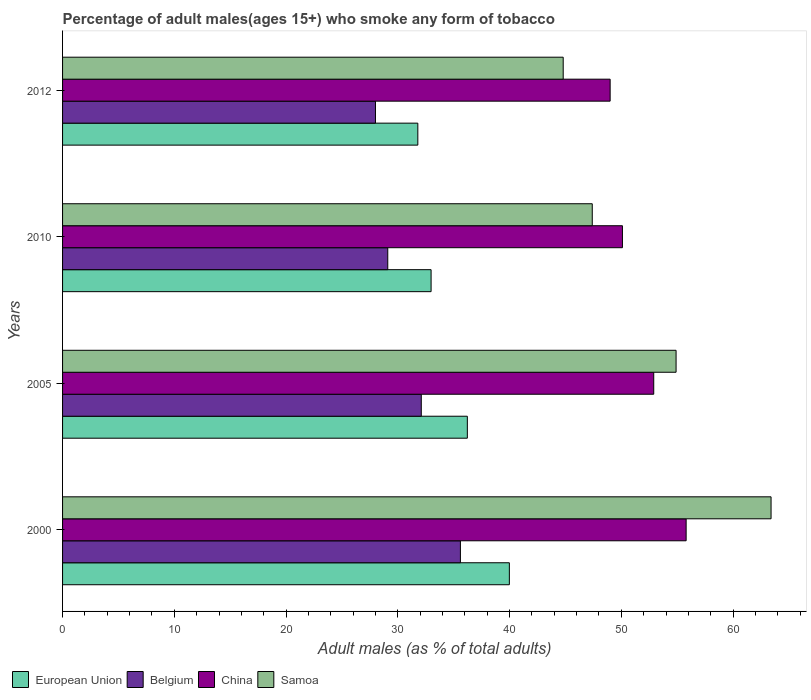How many different coloured bars are there?
Ensure brevity in your answer.  4. How many groups of bars are there?
Provide a succinct answer. 4. Are the number of bars per tick equal to the number of legend labels?
Ensure brevity in your answer.  Yes. Are the number of bars on each tick of the Y-axis equal?
Your response must be concise. Yes. What is the label of the 1st group of bars from the top?
Ensure brevity in your answer.  2012. In how many cases, is the number of bars for a given year not equal to the number of legend labels?
Your answer should be compact. 0. What is the percentage of adult males who smoke in China in 2000?
Offer a very short reply. 55.8. Across all years, what is the maximum percentage of adult males who smoke in China?
Your answer should be very brief. 55.8. Across all years, what is the minimum percentage of adult males who smoke in European Union?
Offer a terse response. 31.79. What is the total percentage of adult males who smoke in European Union in the graph?
Give a very brief answer. 140.97. What is the difference between the percentage of adult males who smoke in European Union in 2000 and that in 2012?
Give a very brief answer. 8.19. What is the difference between the percentage of adult males who smoke in European Union in 2010 and the percentage of adult males who smoke in China in 2000?
Ensure brevity in your answer.  -22.82. What is the average percentage of adult males who smoke in Belgium per year?
Your answer should be very brief. 31.2. In the year 2000, what is the difference between the percentage of adult males who smoke in European Union and percentage of adult males who smoke in Belgium?
Make the answer very short. 4.38. In how many years, is the percentage of adult males who smoke in Samoa greater than 30 %?
Offer a terse response. 4. What is the ratio of the percentage of adult males who smoke in European Union in 2000 to that in 2010?
Your answer should be compact. 1.21. Is the percentage of adult males who smoke in European Union in 2005 less than that in 2010?
Keep it short and to the point. No. Is the difference between the percentage of adult males who smoke in European Union in 2000 and 2005 greater than the difference between the percentage of adult males who smoke in Belgium in 2000 and 2005?
Keep it short and to the point. Yes. What is the difference between the highest and the second highest percentage of adult males who smoke in China?
Ensure brevity in your answer.  2.9. What is the difference between the highest and the lowest percentage of adult males who smoke in Samoa?
Keep it short and to the point. 18.6. In how many years, is the percentage of adult males who smoke in China greater than the average percentage of adult males who smoke in China taken over all years?
Provide a short and direct response. 2. Is the sum of the percentage of adult males who smoke in China in 2010 and 2012 greater than the maximum percentage of adult males who smoke in Samoa across all years?
Your answer should be very brief. Yes. What does the 3rd bar from the bottom in 2005 represents?
Make the answer very short. China. Are all the bars in the graph horizontal?
Offer a terse response. Yes. What is the difference between two consecutive major ticks on the X-axis?
Give a very brief answer. 10. Are the values on the major ticks of X-axis written in scientific E-notation?
Give a very brief answer. No. Does the graph contain grids?
Make the answer very short. No. How are the legend labels stacked?
Make the answer very short. Horizontal. What is the title of the graph?
Your answer should be very brief. Percentage of adult males(ages 15+) who smoke any form of tobacco. Does "Albania" appear as one of the legend labels in the graph?
Provide a succinct answer. No. What is the label or title of the X-axis?
Give a very brief answer. Adult males (as % of total adults). What is the label or title of the Y-axis?
Offer a very short reply. Years. What is the Adult males (as % of total adults) of European Union in 2000?
Your answer should be very brief. 39.98. What is the Adult males (as % of total adults) in Belgium in 2000?
Ensure brevity in your answer.  35.6. What is the Adult males (as % of total adults) in China in 2000?
Give a very brief answer. 55.8. What is the Adult males (as % of total adults) of Samoa in 2000?
Make the answer very short. 63.4. What is the Adult males (as % of total adults) of European Union in 2005?
Your answer should be compact. 36.22. What is the Adult males (as % of total adults) in Belgium in 2005?
Your answer should be very brief. 32.1. What is the Adult males (as % of total adults) in China in 2005?
Offer a terse response. 52.9. What is the Adult males (as % of total adults) in Samoa in 2005?
Your response must be concise. 54.9. What is the Adult males (as % of total adults) in European Union in 2010?
Your answer should be compact. 32.98. What is the Adult males (as % of total adults) in Belgium in 2010?
Provide a short and direct response. 29.1. What is the Adult males (as % of total adults) of China in 2010?
Make the answer very short. 50.1. What is the Adult males (as % of total adults) in Samoa in 2010?
Provide a succinct answer. 47.4. What is the Adult males (as % of total adults) of European Union in 2012?
Provide a short and direct response. 31.79. What is the Adult males (as % of total adults) in China in 2012?
Give a very brief answer. 49. What is the Adult males (as % of total adults) of Samoa in 2012?
Offer a terse response. 44.8. Across all years, what is the maximum Adult males (as % of total adults) of European Union?
Provide a succinct answer. 39.98. Across all years, what is the maximum Adult males (as % of total adults) of Belgium?
Make the answer very short. 35.6. Across all years, what is the maximum Adult males (as % of total adults) of China?
Provide a succinct answer. 55.8. Across all years, what is the maximum Adult males (as % of total adults) of Samoa?
Give a very brief answer. 63.4. Across all years, what is the minimum Adult males (as % of total adults) in European Union?
Offer a very short reply. 31.79. Across all years, what is the minimum Adult males (as % of total adults) in Samoa?
Provide a short and direct response. 44.8. What is the total Adult males (as % of total adults) of European Union in the graph?
Give a very brief answer. 140.97. What is the total Adult males (as % of total adults) of Belgium in the graph?
Provide a succinct answer. 124.8. What is the total Adult males (as % of total adults) in China in the graph?
Ensure brevity in your answer.  207.8. What is the total Adult males (as % of total adults) of Samoa in the graph?
Offer a terse response. 210.5. What is the difference between the Adult males (as % of total adults) in European Union in 2000 and that in 2005?
Keep it short and to the point. 3.76. What is the difference between the Adult males (as % of total adults) in Samoa in 2000 and that in 2005?
Ensure brevity in your answer.  8.5. What is the difference between the Adult males (as % of total adults) of European Union in 2000 and that in 2010?
Give a very brief answer. 7. What is the difference between the Adult males (as % of total adults) of China in 2000 and that in 2010?
Provide a short and direct response. 5.7. What is the difference between the Adult males (as % of total adults) in European Union in 2000 and that in 2012?
Give a very brief answer. 8.19. What is the difference between the Adult males (as % of total adults) of Samoa in 2000 and that in 2012?
Ensure brevity in your answer.  18.6. What is the difference between the Adult males (as % of total adults) of European Union in 2005 and that in 2010?
Keep it short and to the point. 3.24. What is the difference between the Adult males (as % of total adults) of China in 2005 and that in 2010?
Offer a terse response. 2.8. What is the difference between the Adult males (as % of total adults) in European Union in 2005 and that in 2012?
Make the answer very short. 4.43. What is the difference between the Adult males (as % of total adults) of China in 2005 and that in 2012?
Keep it short and to the point. 3.9. What is the difference between the Adult males (as % of total adults) in European Union in 2010 and that in 2012?
Keep it short and to the point. 1.19. What is the difference between the Adult males (as % of total adults) of European Union in 2000 and the Adult males (as % of total adults) of Belgium in 2005?
Your answer should be very brief. 7.88. What is the difference between the Adult males (as % of total adults) in European Union in 2000 and the Adult males (as % of total adults) in China in 2005?
Offer a very short reply. -12.92. What is the difference between the Adult males (as % of total adults) in European Union in 2000 and the Adult males (as % of total adults) in Samoa in 2005?
Keep it short and to the point. -14.92. What is the difference between the Adult males (as % of total adults) of Belgium in 2000 and the Adult males (as % of total adults) of China in 2005?
Your response must be concise. -17.3. What is the difference between the Adult males (as % of total adults) in Belgium in 2000 and the Adult males (as % of total adults) in Samoa in 2005?
Offer a very short reply. -19.3. What is the difference between the Adult males (as % of total adults) of China in 2000 and the Adult males (as % of total adults) of Samoa in 2005?
Your response must be concise. 0.9. What is the difference between the Adult males (as % of total adults) in European Union in 2000 and the Adult males (as % of total adults) in Belgium in 2010?
Your response must be concise. 10.88. What is the difference between the Adult males (as % of total adults) in European Union in 2000 and the Adult males (as % of total adults) in China in 2010?
Give a very brief answer. -10.12. What is the difference between the Adult males (as % of total adults) in European Union in 2000 and the Adult males (as % of total adults) in Samoa in 2010?
Your answer should be compact. -7.42. What is the difference between the Adult males (as % of total adults) in Belgium in 2000 and the Adult males (as % of total adults) in China in 2010?
Ensure brevity in your answer.  -14.5. What is the difference between the Adult males (as % of total adults) of Belgium in 2000 and the Adult males (as % of total adults) of Samoa in 2010?
Your response must be concise. -11.8. What is the difference between the Adult males (as % of total adults) in European Union in 2000 and the Adult males (as % of total adults) in Belgium in 2012?
Your answer should be very brief. 11.98. What is the difference between the Adult males (as % of total adults) in European Union in 2000 and the Adult males (as % of total adults) in China in 2012?
Make the answer very short. -9.02. What is the difference between the Adult males (as % of total adults) of European Union in 2000 and the Adult males (as % of total adults) of Samoa in 2012?
Give a very brief answer. -4.82. What is the difference between the Adult males (as % of total adults) of China in 2000 and the Adult males (as % of total adults) of Samoa in 2012?
Provide a succinct answer. 11. What is the difference between the Adult males (as % of total adults) of European Union in 2005 and the Adult males (as % of total adults) of Belgium in 2010?
Provide a succinct answer. 7.12. What is the difference between the Adult males (as % of total adults) of European Union in 2005 and the Adult males (as % of total adults) of China in 2010?
Make the answer very short. -13.88. What is the difference between the Adult males (as % of total adults) in European Union in 2005 and the Adult males (as % of total adults) in Samoa in 2010?
Your answer should be very brief. -11.18. What is the difference between the Adult males (as % of total adults) in Belgium in 2005 and the Adult males (as % of total adults) in Samoa in 2010?
Offer a very short reply. -15.3. What is the difference between the Adult males (as % of total adults) in China in 2005 and the Adult males (as % of total adults) in Samoa in 2010?
Make the answer very short. 5.5. What is the difference between the Adult males (as % of total adults) of European Union in 2005 and the Adult males (as % of total adults) of Belgium in 2012?
Keep it short and to the point. 8.22. What is the difference between the Adult males (as % of total adults) in European Union in 2005 and the Adult males (as % of total adults) in China in 2012?
Your response must be concise. -12.78. What is the difference between the Adult males (as % of total adults) of European Union in 2005 and the Adult males (as % of total adults) of Samoa in 2012?
Keep it short and to the point. -8.58. What is the difference between the Adult males (as % of total adults) of Belgium in 2005 and the Adult males (as % of total adults) of China in 2012?
Give a very brief answer. -16.9. What is the difference between the Adult males (as % of total adults) of Belgium in 2005 and the Adult males (as % of total adults) of Samoa in 2012?
Ensure brevity in your answer.  -12.7. What is the difference between the Adult males (as % of total adults) in China in 2005 and the Adult males (as % of total adults) in Samoa in 2012?
Provide a short and direct response. 8.1. What is the difference between the Adult males (as % of total adults) in European Union in 2010 and the Adult males (as % of total adults) in Belgium in 2012?
Provide a short and direct response. 4.98. What is the difference between the Adult males (as % of total adults) of European Union in 2010 and the Adult males (as % of total adults) of China in 2012?
Provide a short and direct response. -16.02. What is the difference between the Adult males (as % of total adults) of European Union in 2010 and the Adult males (as % of total adults) of Samoa in 2012?
Provide a succinct answer. -11.82. What is the difference between the Adult males (as % of total adults) of Belgium in 2010 and the Adult males (as % of total adults) of China in 2012?
Your answer should be very brief. -19.9. What is the difference between the Adult males (as % of total adults) of Belgium in 2010 and the Adult males (as % of total adults) of Samoa in 2012?
Make the answer very short. -15.7. What is the average Adult males (as % of total adults) in European Union per year?
Keep it short and to the point. 35.24. What is the average Adult males (as % of total adults) of Belgium per year?
Your answer should be compact. 31.2. What is the average Adult males (as % of total adults) in China per year?
Ensure brevity in your answer.  51.95. What is the average Adult males (as % of total adults) of Samoa per year?
Give a very brief answer. 52.62. In the year 2000, what is the difference between the Adult males (as % of total adults) of European Union and Adult males (as % of total adults) of Belgium?
Provide a succinct answer. 4.38. In the year 2000, what is the difference between the Adult males (as % of total adults) of European Union and Adult males (as % of total adults) of China?
Give a very brief answer. -15.82. In the year 2000, what is the difference between the Adult males (as % of total adults) of European Union and Adult males (as % of total adults) of Samoa?
Your answer should be compact. -23.42. In the year 2000, what is the difference between the Adult males (as % of total adults) in Belgium and Adult males (as % of total adults) in China?
Give a very brief answer. -20.2. In the year 2000, what is the difference between the Adult males (as % of total adults) in Belgium and Adult males (as % of total adults) in Samoa?
Make the answer very short. -27.8. In the year 2000, what is the difference between the Adult males (as % of total adults) in China and Adult males (as % of total adults) in Samoa?
Your answer should be compact. -7.6. In the year 2005, what is the difference between the Adult males (as % of total adults) in European Union and Adult males (as % of total adults) in Belgium?
Ensure brevity in your answer.  4.12. In the year 2005, what is the difference between the Adult males (as % of total adults) in European Union and Adult males (as % of total adults) in China?
Your response must be concise. -16.68. In the year 2005, what is the difference between the Adult males (as % of total adults) of European Union and Adult males (as % of total adults) of Samoa?
Provide a short and direct response. -18.68. In the year 2005, what is the difference between the Adult males (as % of total adults) in Belgium and Adult males (as % of total adults) in China?
Provide a short and direct response. -20.8. In the year 2005, what is the difference between the Adult males (as % of total adults) of Belgium and Adult males (as % of total adults) of Samoa?
Offer a terse response. -22.8. In the year 2005, what is the difference between the Adult males (as % of total adults) of China and Adult males (as % of total adults) of Samoa?
Provide a succinct answer. -2. In the year 2010, what is the difference between the Adult males (as % of total adults) in European Union and Adult males (as % of total adults) in Belgium?
Offer a terse response. 3.88. In the year 2010, what is the difference between the Adult males (as % of total adults) of European Union and Adult males (as % of total adults) of China?
Offer a terse response. -17.12. In the year 2010, what is the difference between the Adult males (as % of total adults) of European Union and Adult males (as % of total adults) of Samoa?
Give a very brief answer. -14.42. In the year 2010, what is the difference between the Adult males (as % of total adults) in Belgium and Adult males (as % of total adults) in Samoa?
Make the answer very short. -18.3. In the year 2012, what is the difference between the Adult males (as % of total adults) in European Union and Adult males (as % of total adults) in Belgium?
Keep it short and to the point. 3.79. In the year 2012, what is the difference between the Adult males (as % of total adults) in European Union and Adult males (as % of total adults) in China?
Offer a very short reply. -17.21. In the year 2012, what is the difference between the Adult males (as % of total adults) in European Union and Adult males (as % of total adults) in Samoa?
Keep it short and to the point. -13.01. In the year 2012, what is the difference between the Adult males (as % of total adults) of Belgium and Adult males (as % of total adults) of Samoa?
Offer a terse response. -16.8. In the year 2012, what is the difference between the Adult males (as % of total adults) of China and Adult males (as % of total adults) of Samoa?
Provide a short and direct response. 4.2. What is the ratio of the Adult males (as % of total adults) in European Union in 2000 to that in 2005?
Keep it short and to the point. 1.1. What is the ratio of the Adult males (as % of total adults) of Belgium in 2000 to that in 2005?
Your answer should be very brief. 1.11. What is the ratio of the Adult males (as % of total adults) of China in 2000 to that in 2005?
Provide a short and direct response. 1.05. What is the ratio of the Adult males (as % of total adults) in Samoa in 2000 to that in 2005?
Make the answer very short. 1.15. What is the ratio of the Adult males (as % of total adults) in European Union in 2000 to that in 2010?
Provide a succinct answer. 1.21. What is the ratio of the Adult males (as % of total adults) of Belgium in 2000 to that in 2010?
Keep it short and to the point. 1.22. What is the ratio of the Adult males (as % of total adults) of China in 2000 to that in 2010?
Make the answer very short. 1.11. What is the ratio of the Adult males (as % of total adults) in Samoa in 2000 to that in 2010?
Offer a terse response. 1.34. What is the ratio of the Adult males (as % of total adults) of European Union in 2000 to that in 2012?
Make the answer very short. 1.26. What is the ratio of the Adult males (as % of total adults) in Belgium in 2000 to that in 2012?
Give a very brief answer. 1.27. What is the ratio of the Adult males (as % of total adults) of China in 2000 to that in 2012?
Give a very brief answer. 1.14. What is the ratio of the Adult males (as % of total adults) of Samoa in 2000 to that in 2012?
Offer a very short reply. 1.42. What is the ratio of the Adult males (as % of total adults) of European Union in 2005 to that in 2010?
Ensure brevity in your answer.  1.1. What is the ratio of the Adult males (as % of total adults) in Belgium in 2005 to that in 2010?
Your answer should be compact. 1.1. What is the ratio of the Adult males (as % of total adults) in China in 2005 to that in 2010?
Your response must be concise. 1.06. What is the ratio of the Adult males (as % of total adults) of Samoa in 2005 to that in 2010?
Keep it short and to the point. 1.16. What is the ratio of the Adult males (as % of total adults) of European Union in 2005 to that in 2012?
Make the answer very short. 1.14. What is the ratio of the Adult males (as % of total adults) in Belgium in 2005 to that in 2012?
Your response must be concise. 1.15. What is the ratio of the Adult males (as % of total adults) in China in 2005 to that in 2012?
Offer a terse response. 1.08. What is the ratio of the Adult males (as % of total adults) in Samoa in 2005 to that in 2012?
Keep it short and to the point. 1.23. What is the ratio of the Adult males (as % of total adults) of European Union in 2010 to that in 2012?
Give a very brief answer. 1.04. What is the ratio of the Adult males (as % of total adults) in Belgium in 2010 to that in 2012?
Keep it short and to the point. 1.04. What is the ratio of the Adult males (as % of total adults) in China in 2010 to that in 2012?
Your answer should be very brief. 1.02. What is the ratio of the Adult males (as % of total adults) of Samoa in 2010 to that in 2012?
Make the answer very short. 1.06. What is the difference between the highest and the second highest Adult males (as % of total adults) in European Union?
Ensure brevity in your answer.  3.76. What is the difference between the highest and the second highest Adult males (as % of total adults) of Belgium?
Ensure brevity in your answer.  3.5. What is the difference between the highest and the second highest Adult males (as % of total adults) of Samoa?
Offer a very short reply. 8.5. What is the difference between the highest and the lowest Adult males (as % of total adults) in European Union?
Make the answer very short. 8.19. What is the difference between the highest and the lowest Adult males (as % of total adults) of Belgium?
Your answer should be very brief. 7.6. What is the difference between the highest and the lowest Adult males (as % of total adults) in China?
Keep it short and to the point. 6.8. 